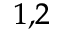<formula> <loc_0><loc_0><loc_500><loc_500>^ { 1 , 2 }</formula> 